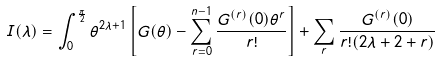Convert formula to latex. <formula><loc_0><loc_0><loc_500><loc_500>I ( \lambda ) = \int ^ { \frac { \pi } { 2 } } _ { 0 } \theta ^ { 2 \lambda + 1 } \left [ G ( \theta ) - \sum ^ { n - 1 } _ { r = 0 } \frac { G ^ { ( r ) } ( 0 ) \theta ^ { r } } { r ! } \right ] + \sum _ { r } \frac { G ^ { ( r ) } ( 0 ) } { r ! ( 2 \lambda + 2 + r ) }</formula> 